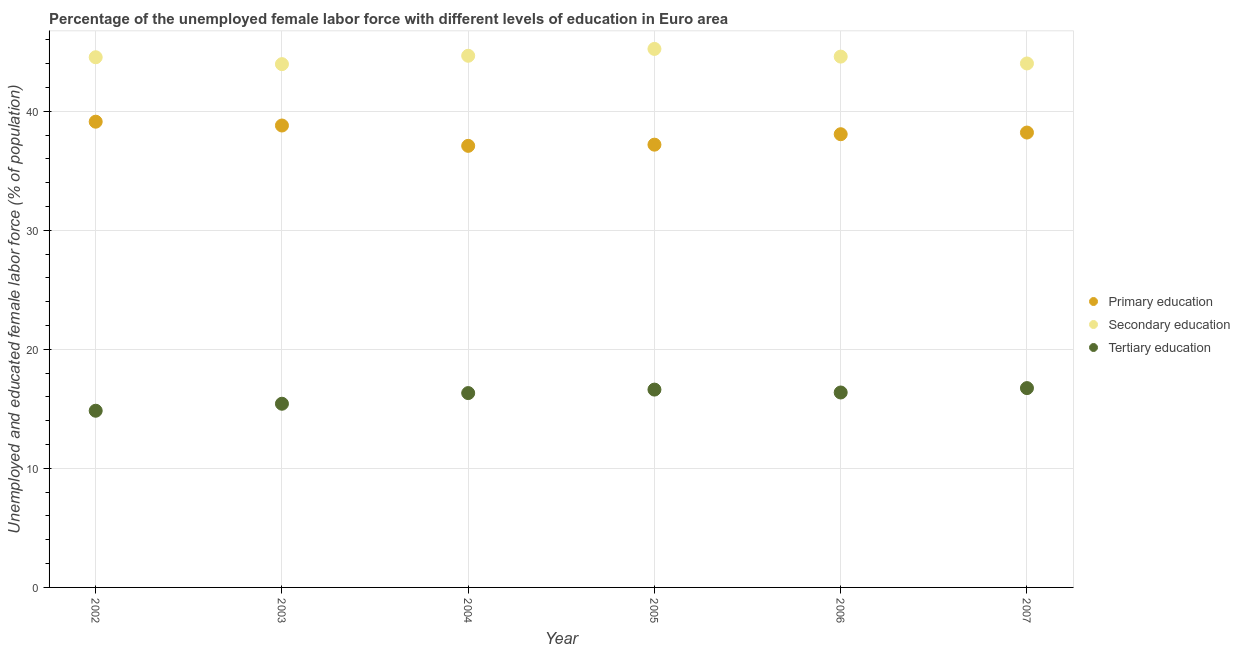What is the percentage of female labor force who received primary education in 2006?
Provide a short and direct response. 38.07. Across all years, what is the maximum percentage of female labor force who received secondary education?
Your answer should be compact. 45.23. Across all years, what is the minimum percentage of female labor force who received secondary education?
Your response must be concise. 43.96. In which year was the percentage of female labor force who received tertiary education maximum?
Your answer should be compact. 2007. What is the total percentage of female labor force who received secondary education in the graph?
Ensure brevity in your answer.  266.99. What is the difference between the percentage of female labor force who received tertiary education in 2002 and that in 2003?
Ensure brevity in your answer.  -0.59. What is the difference between the percentage of female labor force who received tertiary education in 2006 and the percentage of female labor force who received primary education in 2002?
Your answer should be compact. -22.75. What is the average percentage of female labor force who received primary education per year?
Provide a succinct answer. 38.08. In the year 2003, what is the difference between the percentage of female labor force who received secondary education and percentage of female labor force who received primary education?
Offer a terse response. 5.16. What is the ratio of the percentage of female labor force who received tertiary education in 2002 to that in 2005?
Give a very brief answer. 0.89. Is the percentage of female labor force who received primary education in 2002 less than that in 2003?
Provide a succinct answer. No. What is the difference between the highest and the second highest percentage of female labor force who received secondary education?
Your answer should be compact. 0.58. What is the difference between the highest and the lowest percentage of female labor force who received tertiary education?
Offer a terse response. 1.9. Is it the case that in every year, the sum of the percentage of female labor force who received primary education and percentage of female labor force who received secondary education is greater than the percentage of female labor force who received tertiary education?
Your answer should be very brief. Yes. Is the percentage of female labor force who received primary education strictly less than the percentage of female labor force who received tertiary education over the years?
Your answer should be very brief. No. How many dotlines are there?
Your answer should be very brief. 3. What is the difference between two consecutive major ticks on the Y-axis?
Your response must be concise. 10. Are the values on the major ticks of Y-axis written in scientific E-notation?
Your answer should be compact. No. Does the graph contain grids?
Ensure brevity in your answer.  Yes. How many legend labels are there?
Give a very brief answer. 3. How are the legend labels stacked?
Provide a succinct answer. Vertical. What is the title of the graph?
Provide a succinct answer. Percentage of the unemployed female labor force with different levels of education in Euro area. Does "Central government" appear as one of the legend labels in the graph?
Give a very brief answer. No. What is the label or title of the Y-axis?
Offer a terse response. Unemployed and educated female labor force (% of population). What is the Unemployed and educated female labor force (% of population) in Primary education in 2002?
Give a very brief answer. 39.12. What is the Unemployed and educated female labor force (% of population) in Secondary education in 2002?
Keep it short and to the point. 44.53. What is the Unemployed and educated female labor force (% of population) of Tertiary education in 2002?
Your answer should be compact. 14.84. What is the Unemployed and educated female labor force (% of population) of Primary education in 2003?
Your answer should be very brief. 38.8. What is the Unemployed and educated female labor force (% of population) in Secondary education in 2003?
Offer a terse response. 43.96. What is the Unemployed and educated female labor force (% of population) of Tertiary education in 2003?
Offer a very short reply. 15.43. What is the Unemployed and educated female labor force (% of population) of Primary education in 2004?
Keep it short and to the point. 37.09. What is the Unemployed and educated female labor force (% of population) in Secondary education in 2004?
Offer a very short reply. 44.66. What is the Unemployed and educated female labor force (% of population) of Tertiary education in 2004?
Provide a short and direct response. 16.32. What is the Unemployed and educated female labor force (% of population) of Primary education in 2005?
Offer a terse response. 37.19. What is the Unemployed and educated female labor force (% of population) in Secondary education in 2005?
Your response must be concise. 45.23. What is the Unemployed and educated female labor force (% of population) of Tertiary education in 2005?
Offer a very short reply. 16.62. What is the Unemployed and educated female labor force (% of population) of Primary education in 2006?
Offer a very short reply. 38.07. What is the Unemployed and educated female labor force (% of population) in Secondary education in 2006?
Keep it short and to the point. 44.59. What is the Unemployed and educated female labor force (% of population) of Tertiary education in 2006?
Your response must be concise. 16.37. What is the Unemployed and educated female labor force (% of population) of Primary education in 2007?
Give a very brief answer. 38.21. What is the Unemployed and educated female labor force (% of population) of Secondary education in 2007?
Provide a succinct answer. 44.01. What is the Unemployed and educated female labor force (% of population) in Tertiary education in 2007?
Make the answer very short. 16.74. Across all years, what is the maximum Unemployed and educated female labor force (% of population) of Primary education?
Make the answer very short. 39.12. Across all years, what is the maximum Unemployed and educated female labor force (% of population) in Secondary education?
Ensure brevity in your answer.  45.23. Across all years, what is the maximum Unemployed and educated female labor force (% of population) in Tertiary education?
Your answer should be very brief. 16.74. Across all years, what is the minimum Unemployed and educated female labor force (% of population) in Primary education?
Your response must be concise. 37.09. Across all years, what is the minimum Unemployed and educated female labor force (% of population) of Secondary education?
Make the answer very short. 43.96. Across all years, what is the minimum Unemployed and educated female labor force (% of population) of Tertiary education?
Your answer should be very brief. 14.84. What is the total Unemployed and educated female labor force (% of population) in Primary education in the graph?
Your answer should be very brief. 228.48. What is the total Unemployed and educated female labor force (% of population) in Secondary education in the graph?
Offer a terse response. 266.99. What is the total Unemployed and educated female labor force (% of population) in Tertiary education in the graph?
Your response must be concise. 96.33. What is the difference between the Unemployed and educated female labor force (% of population) in Primary education in 2002 and that in 2003?
Your answer should be very brief. 0.32. What is the difference between the Unemployed and educated female labor force (% of population) in Secondary education in 2002 and that in 2003?
Make the answer very short. 0.58. What is the difference between the Unemployed and educated female labor force (% of population) in Tertiary education in 2002 and that in 2003?
Give a very brief answer. -0.59. What is the difference between the Unemployed and educated female labor force (% of population) in Primary education in 2002 and that in 2004?
Your answer should be very brief. 2.03. What is the difference between the Unemployed and educated female labor force (% of population) of Secondary education in 2002 and that in 2004?
Your answer should be very brief. -0.12. What is the difference between the Unemployed and educated female labor force (% of population) in Tertiary education in 2002 and that in 2004?
Offer a terse response. -1.48. What is the difference between the Unemployed and educated female labor force (% of population) in Primary education in 2002 and that in 2005?
Provide a succinct answer. 1.93. What is the difference between the Unemployed and educated female labor force (% of population) of Tertiary education in 2002 and that in 2005?
Offer a terse response. -1.78. What is the difference between the Unemployed and educated female labor force (% of population) in Primary education in 2002 and that in 2006?
Offer a terse response. 1.05. What is the difference between the Unemployed and educated female labor force (% of population) of Secondary education in 2002 and that in 2006?
Keep it short and to the point. -0.05. What is the difference between the Unemployed and educated female labor force (% of population) of Tertiary education in 2002 and that in 2006?
Give a very brief answer. -1.53. What is the difference between the Unemployed and educated female labor force (% of population) in Primary education in 2002 and that in 2007?
Give a very brief answer. 0.91. What is the difference between the Unemployed and educated female labor force (% of population) of Secondary education in 2002 and that in 2007?
Your answer should be very brief. 0.52. What is the difference between the Unemployed and educated female labor force (% of population) of Tertiary education in 2002 and that in 2007?
Your answer should be compact. -1.9. What is the difference between the Unemployed and educated female labor force (% of population) in Primary education in 2003 and that in 2004?
Your answer should be compact. 1.71. What is the difference between the Unemployed and educated female labor force (% of population) of Secondary education in 2003 and that in 2004?
Keep it short and to the point. -0.7. What is the difference between the Unemployed and educated female labor force (% of population) in Tertiary education in 2003 and that in 2004?
Your answer should be very brief. -0.9. What is the difference between the Unemployed and educated female labor force (% of population) in Primary education in 2003 and that in 2005?
Offer a very short reply. 1.61. What is the difference between the Unemployed and educated female labor force (% of population) of Secondary education in 2003 and that in 2005?
Offer a very short reply. -1.28. What is the difference between the Unemployed and educated female labor force (% of population) in Tertiary education in 2003 and that in 2005?
Ensure brevity in your answer.  -1.19. What is the difference between the Unemployed and educated female labor force (% of population) in Primary education in 2003 and that in 2006?
Your response must be concise. 0.73. What is the difference between the Unemployed and educated female labor force (% of population) in Secondary education in 2003 and that in 2006?
Provide a succinct answer. -0.63. What is the difference between the Unemployed and educated female labor force (% of population) of Tertiary education in 2003 and that in 2006?
Your answer should be compact. -0.94. What is the difference between the Unemployed and educated female labor force (% of population) of Primary education in 2003 and that in 2007?
Your answer should be compact. 0.59. What is the difference between the Unemployed and educated female labor force (% of population) of Secondary education in 2003 and that in 2007?
Your response must be concise. -0.06. What is the difference between the Unemployed and educated female labor force (% of population) in Tertiary education in 2003 and that in 2007?
Your response must be concise. -1.31. What is the difference between the Unemployed and educated female labor force (% of population) of Primary education in 2004 and that in 2005?
Offer a very short reply. -0.1. What is the difference between the Unemployed and educated female labor force (% of population) of Secondary education in 2004 and that in 2005?
Provide a succinct answer. -0.58. What is the difference between the Unemployed and educated female labor force (% of population) of Tertiary education in 2004 and that in 2005?
Your response must be concise. -0.29. What is the difference between the Unemployed and educated female labor force (% of population) in Primary education in 2004 and that in 2006?
Offer a terse response. -0.98. What is the difference between the Unemployed and educated female labor force (% of population) in Secondary education in 2004 and that in 2006?
Provide a succinct answer. 0.07. What is the difference between the Unemployed and educated female labor force (% of population) in Tertiary education in 2004 and that in 2006?
Give a very brief answer. -0.05. What is the difference between the Unemployed and educated female labor force (% of population) in Primary education in 2004 and that in 2007?
Ensure brevity in your answer.  -1.12. What is the difference between the Unemployed and educated female labor force (% of population) of Secondary education in 2004 and that in 2007?
Your response must be concise. 0.65. What is the difference between the Unemployed and educated female labor force (% of population) in Tertiary education in 2004 and that in 2007?
Provide a short and direct response. -0.42. What is the difference between the Unemployed and educated female labor force (% of population) of Primary education in 2005 and that in 2006?
Your answer should be compact. -0.88. What is the difference between the Unemployed and educated female labor force (% of population) of Secondary education in 2005 and that in 2006?
Offer a terse response. 0.65. What is the difference between the Unemployed and educated female labor force (% of population) of Tertiary education in 2005 and that in 2006?
Offer a terse response. 0.24. What is the difference between the Unemployed and educated female labor force (% of population) in Primary education in 2005 and that in 2007?
Provide a succinct answer. -1.02. What is the difference between the Unemployed and educated female labor force (% of population) in Secondary education in 2005 and that in 2007?
Offer a terse response. 1.22. What is the difference between the Unemployed and educated female labor force (% of population) in Tertiary education in 2005 and that in 2007?
Provide a succinct answer. -0.12. What is the difference between the Unemployed and educated female labor force (% of population) of Primary education in 2006 and that in 2007?
Give a very brief answer. -0.14. What is the difference between the Unemployed and educated female labor force (% of population) in Secondary education in 2006 and that in 2007?
Your response must be concise. 0.58. What is the difference between the Unemployed and educated female labor force (% of population) of Tertiary education in 2006 and that in 2007?
Make the answer very short. -0.37. What is the difference between the Unemployed and educated female labor force (% of population) in Primary education in 2002 and the Unemployed and educated female labor force (% of population) in Secondary education in 2003?
Keep it short and to the point. -4.83. What is the difference between the Unemployed and educated female labor force (% of population) of Primary education in 2002 and the Unemployed and educated female labor force (% of population) of Tertiary education in 2003?
Ensure brevity in your answer.  23.69. What is the difference between the Unemployed and educated female labor force (% of population) in Secondary education in 2002 and the Unemployed and educated female labor force (% of population) in Tertiary education in 2003?
Your response must be concise. 29.1. What is the difference between the Unemployed and educated female labor force (% of population) in Primary education in 2002 and the Unemployed and educated female labor force (% of population) in Secondary education in 2004?
Provide a succinct answer. -5.54. What is the difference between the Unemployed and educated female labor force (% of population) in Primary education in 2002 and the Unemployed and educated female labor force (% of population) in Tertiary education in 2004?
Your answer should be compact. 22.8. What is the difference between the Unemployed and educated female labor force (% of population) of Secondary education in 2002 and the Unemployed and educated female labor force (% of population) of Tertiary education in 2004?
Ensure brevity in your answer.  28.21. What is the difference between the Unemployed and educated female labor force (% of population) in Primary education in 2002 and the Unemployed and educated female labor force (% of population) in Secondary education in 2005?
Keep it short and to the point. -6.11. What is the difference between the Unemployed and educated female labor force (% of population) in Primary education in 2002 and the Unemployed and educated female labor force (% of population) in Tertiary education in 2005?
Keep it short and to the point. 22.5. What is the difference between the Unemployed and educated female labor force (% of population) in Secondary education in 2002 and the Unemployed and educated female labor force (% of population) in Tertiary education in 2005?
Offer a very short reply. 27.92. What is the difference between the Unemployed and educated female labor force (% of population) of Primary education in 2002 and the Unemployed and educated female labor force (% of population) of Secondary education in 2006?
Ensure brevity in your answer.  -5.47. What is the difference between the Unemployed and educated female labor force (% of population) of Primary education in 2002 and the Unemployed and educated female labor force (% of population) of Tertiary education in 2006?
Offer a terse response. 22.75. What is the difference between the Unemployed and educated female labor force (% of population) of Secondary education in 2002 and the Unemployed and educated female labor force (% of population) of Tertiary education in 2006?
Provide a succinct answer. 28.16. What is the difference between the Unemployed and educated female labor force (% of population) of Primary education in 2002 and the Unemployed and educated female labor force (% of population) of Secondary education in 2007?
Offer a very short reply. -4.89. What is the difference between the Unemployed and educated female labor force (% of population) in Primary education in 2002 and the Unemployed and educated female labor force (% of population) in Tertiary education in 2007?
Provide a short and direct response. 22.38. What is the difference between the Unemployed and educated female labor force (% of population) of Secondary education in 2002 and the Unemployed and educated female labor force (% of population) of Tertiary education in 2007?
Provide a short and direct response. 27.79. What is the difference between the Unemployed and educated female labor force (% of population) of Primary education in 2003 and the Unemployed and educated female labor force (% of population) of Secondary education in 2004?
Keep it short and to the point. -5.86. What is the difference between the Unemployed and educated female labor force (% of population) in Primary education in 2003 and the Unemployed and educated female labor force (% of population) in Tertiary education in 2004?
Make the answer very short. 22.48. What is the difference between the Unemployed and educated female labor force (% of population) in Secondary education in 2003 and the Unemployed and educated female labor force (% of population) in Tertiary education in 2004?
Your answer should be compact. 27.63. What is the difference between the Unemployed and educated female labor force (% of population) in Primary education in 2003 and the Unemployed and educated female labor force (% of population) in Secondary education in 2005?
Provide a succinct answer. -6.43. What is the difference between the Unemployed and educated female labor force (% of population) in Primary education in 2003 and the Unemployed and educated female labor force (% of population) in Tertiary education in 2005?
Ensure brevity in your answer.  22.18. What is the difference between the Unemployed and educated female labor force (% of population) in Secondary education in 2003 and the Unemployed and educated female labor force (% of population) in Tertiary education in 2005?
Provide a succinct answer. 27.34. What is the difference between the Unemployed and educated female labor force (% of population) in Primary education in 2003 and the Unemployed and educated female labor force (% of population) in Secondary education in 2006?
Make the answer very short. -5.79. What is the difference between the Unemployed and educated female labor force (% of population) in Primary education in 2003 and the Unemployed and educated female labor force (% of population) in Tertiary education in 2006?
Ensure brevity in your answer.  22.43. What is the difference between the Unemployed and educated female labor force (% of population) in Secondary education in 2003 and the Unemployed and educated female labor force (% of population) in Tertiary education in 2006?
Give a very brief answer. 27.58. What is the difference between the Unemployed and educated female labor force (% of population) in Primary education in 2003 and the Unemployed and educated female labor force (% of population) in Secondary education in 2007?
Your response must be concise. -5.21. What is the difference between the Unemployed and educated female labor force (% of population) of Primary education in 2003 and the Unemployed and educated female labor force (% of population) of Tertiary education in 2007?
Offer a terse response. 22.06. What is the difference between the Unemployed and educated female labor force (% of population) in Secondary education in 2003 and the Unemployed and educated female labor force (% of population) in Tertiary education in 2007?
Provide a short and direct response. 27.21. What is the difference between the Unemployed and educated female labor force (% of population) of Primary education in 2004 and the Unemployed and educated female labor force (% of population) of Secondary education in 2005?
Make the answer very short. -8.14. What is the difference between the Unemployed and educated female labor force (% of population) in Primary education in 2004 and the Unemployed and educated female labor force (% of population) in Tertiary education in 2005?
Offer a terse response. 20.47. What is the difference between the Unemployed and educated female labor force (% of population) in Secondary education in 2004 and the Unemployed and educated female labor force (% of population) in Tertiary education in 2005?
Make the answer very short. 28.04. What is the difference between the Unemployed and educated female labor force (% of population) of Primary education in 2004 and the Unemployed and educated female labor force (% of population) of Secondary education in 2006?
Offer a very short reply. -7.5. What is the difference between the Unemployed and educated female labor force (% of population) in Primary education in 2004 and the Unemployed and educated female labor force (% of population) in Tertiary education in 2006?
Make the answer very short. 20.72. What is the difference between the Unemployed and educated female labor force (% of population) in Secondary education in 2004 and the Unemployed and educated female labor force (% of population) in Tertiary education in 2006?
Your answer should be compact. 28.28. What is the difference between the Unemployed and educated female labor force (% of population) in Primary education in 2004 and the Unemployed and educated female labor force (% of population) in Secondary education in 2007?
Your response must be concise. -6.92. What is the difference between the Unemployed and educated female labor force (% of population) of Primary education in 2004 and the Unemployed and educated female labor force (% of population) of Tertiary education in 2007?
Your answer should be compact. 20.35. What is the difference between the Unemployed and educated female labor force (% of population) of Secondary education in 2004 and the Unemployed and educated female labor force (% of population) of Tertiary education in 2007?
Keep it short and to the point. 27.92. What is the difference between the Unemployed and educated female labor force (% of population) of Primary education in 2005 and the Unemployed and educated female labor force (% of population) of Secondary education in 2006?
Keep it short and to the point. -7.4. What is the difference between the Unemployed and educated female labor force (% of population) of Primary education in 2005 and the Unemployed and educated female labor force (% of population) of Tertiary education in 2006?
Provide a succinct answer. 20.82. What is the difference between the Unemployed and educated female labor force (% of population) in Secondary education in 2005 and the Unemployed and educated female labor force (% of population) in Tertiary education in 2006?
Your answer should be very brief. 28.86. What is the difference between the Unemployed and educated female labor force (% of population) of Primary education in 2005 and the Unemployed and educated female labor force (% of population) of Secondary education in 2007?
Give a very brief answer. -6.82. What is the difference between the Unemployed and educated female labor force (% of population) in Primary education in 2005 and the Unemployed and educated female labor force (% of population) in Tertiary education in 2007?
Your answer should be compact. 20.45. What is the difference between the Unemployed and educated female labor force (% of population) in Secondary education in 2005 and the Unemployed and educated female labor force (% of population) in Tertiary education in 2007?
Make the answer very short. 28.49. What is the difference between the Unemployed and educated female labor force (% of population) of Primary education in 2006 and the Unemployed and educated female labor force (% of population) of Secondary education in 2007?
Ensure brevity in your answer.  -5.94. What is the difference between the Unemployed and educated female labor force (% of population) of Primary education in 2006 and the Unemployed and educated female labor force (% of population) of Tertiary education in 2007?
Give a very brief answer. 21.33. What is the difference between the Unemployed and educated female labor force (% of population) in Secondary education in 2006 and the Unemployed and educated female labor force (% of population) in Tertiary education in 2007?
Provide a succinct answer. 27.85. What is the average Unemployed and educated female labor force (% of population) in Primary education per year?
Make the answer very short. 38.08. What is the average Unemployed and educated female labor force (% of population) in Secondary education per year?
Provide a short and direct response. 44.5. What is the average Unemployed and educated female labor force (% of population) in Tertiary education per year?
Ensure brevity in your answer.  16.06. In the year 2002, what is the difference between the Unemployed and educated female labor force (% of population) in Primary education and Unemployed and educated female labor force (% of population) in Secondary education?
Offer a very short reply. -5.41. In the year 2002, what is the difference between the Unemployed and educated female labor force (% of population) in Primary education and Unemployed and educated female labor force (% of population) in Tertiary education?
Ensure brevity in your answer.  24.28. In the year 2002, what is the difference between the Unemployed and educated female labor force (% of population) of Secondary education and Unemployed and educated female labor force (% of population) of Tertiary education?
Provide a succinct answer. 29.69. In the year 2003, what is the difference between the Unemployed and educated female labor force (% of population) of Primary education and Unemployed and educated female labor force (% of population) of Secondary education?
Make the answer very short. -5.16. In the year 2003, what is the difference between the Unemployed and educated female labor force (% of population) in Primary education and Unemployed and educated female labor force (% of population) in Tertiary education?
Provide a short and direct response. 23.37. In the year 2003, what is the difference between the Unemployed and educated female labor force (% of population) in Secondary education and Unemployed and educated female labor force (% of population) in Tertiary education?
Your response must be concise. 28.53. In the year 2004, what is the difference between the Unemployed and educated female labor force (% of population) in Primary education and Unemployed and educated female labor force (% of population) in Secondary education?
Give a very brief answer. -7.57. In the year 2004, what is the difference between the Unemployed and educated female labor force (% of population) of Primary education and Unemployed and educated female labor force (% of population) of Tertiary education?
Your response must be concise. 20.77. In the year 2004, what is the difference between the Unemployed and educated female labor force (% of population) in Secondary education and Unemployed and educated female labor force (% of population) in Tertiary education?
Ensure brevity in your answer.  28.33. In the year 2005, what is the difference between the Unemployed and educated female labor force (% of population) in Primary education and Unemployed and educated female labor force (% of population) in Secondary education?
Offer a terse response. -8.04. In the year 2005, what is the difference between the Unemployed and educated female labor force (% of population) of Primary education and Unemployed and educated female labor force (% of population) of Tertiary education?
Your response must be concise. 20.57. In the year 2005, what is the difference between the Unemployed and educated female labor force (% of population) of Secondary education and Unemployed and educated female labor force (% of population) of Tertiary education?
Your answer should be compact. 28.62. In the year 2006, what is the difference between the Unemployed and educated female labor force (% of population) in Primary education and Unemployed and educated female labor force (% of population) in Secondary education?
Your response must be concise. -6.52. In the year 2006, what is the difference between the Unemployed and educated female labor force (% of population) in Primary education and Unemployed and educated female labor force (% of population) in Tertiary education?
Give a very brief answer. 21.7. In the year 2006, what is the difference between the Unemployed and educated female labor force (% of population) of Secondary education and Unemployed and educated female labor force (% of population) of Tertiary education?
Make the answer very short. 28.21. In the year 2007, what is the difference between the Unemployed and educated female labor force (% of population) in Primary education and Unemployed and educated female labor force (% of population) in Secondary education?
Provide a short and direct response. -5.8. In the year 2007, what is the difference between the Unemployed and educated female labor force (% of population) in Primary education and Unemployed and educated female labor force (% of population) in Tertiary education?
Your response must be concise. 21.47. In the year 2007, what is the difference between the Unemployed and educated female labor force (% of population) in Secondary education and Unemployed and educated female labor force (% of population) in Tertiary education?
Make the answer very short. 27.27. What is the ratio of the Unemployed and educated female labor force (% of population) of Primary education in 2002 to that in 2003?
Your answer should be compact. 1.01. What is the ratio of the Unemployed and educated female labor force (% of population) in Secondary education in 2002 to that in 2003?
Keep it short and to the point. 1.01. What is the ratio of the Unemployed and educated female labor force (% of population) of Tertiary education in 2002 to that in 2003?
Provide a succinct answer. 0.96. What is the ratio of the Unemployed and educated female labor force (% of population) of Primary education in 2002 to that in 2004?
Ensure brevity in your answer.  1.05. What is the ratio of the Unemployed and educated female labor force (% of population) in Tertiary education in 2002 to that in 2004?
Give a very brief answer. 0.91. What is the ratio of the Unemployed and educated female labor force (% of population) of Primary education in 2002 to that in 2005?
Offer a terse response. 1.05. What is the ratio of the Unemployed and educated female labor force (% of population) of Secondary education in 2002 to that in 2005?
Your answer should be compact. 0.98. What is the ratio of the Unemployed and educated female labor force (% of population) in Tertiary education in 2002 to that in 2005?
Give a very brief answer. 0.89. What is the ratio of the Unemployed and educated female labor force (% of population) of Primary education in 2002 to that in 2006?
Provide a short and direct response. 1.03. What is the ratio of the Unemployed and educated female labor force (% of population) of Tertiary education in 2002 to that in 2006?
Provide a succinct answer. 0.91. What is the ratio of the Unemployed and educated female labor force (% of population) in Primary education in 2002 to that in 2007?
Give a very brief answer. 1.02. What is the ratio of the Unemployed and educated female labor force (% of population) of Secondary education in 2002 to that in 2007?
Offer a very short reply. 1.01. What is the ratio of the Unemployed and educated female labor force (% of population) of Tertiary education in 2002 to that in 2007?
Offer a terse response. 0.89. What is the ratio of the Unemployed and educated female labor force (% of population) of Primary education in 2003 to that in 2004?
Keep it short and to the point. 1.05. What is the ratio of the Unemployed and educated female labor force (% of population) of Secondary education in 2003 to that in 2004?
Your answer should be very brief. 0.98. What is the ratio of the Unemployed and educated female labor force (% of population) in Tertiary education in 2003 to that in 2004?
Offer a terse response. 0.95. What is the ratio of the Unemployed and educated female labor force (% of population) of Primary education in 2003 to that in 2005?
Provide a short and direct response. 1.04. What is the ratio of the Unemployed and educated female labor force (% of population) in Secondary education in 2003 to that in 2005?
Your answer should be very brief. 0.97. What is the ratio of the Unemployed and educated female labor force (% of population) in Tertiary education in 2003 to that in 2005?
Provide a succinct answer. 0.93. What is the ratio of the Unemployed and educated female labor force (% of population) of Primary education in 2003 to that in 2006?
Provide a succinct answer. 1.02. What is the ratio of the Unemployed and educated female labor force (% of population) of Secondary education in 2003 to that in 2006?
Give a very brief answer. 0.99. What is the ratio of the Unemployed and educated female labor force (% of population) of Tertiary education in 2003 to that in 2006?
Provide a succinct answer. 0.94. What is the ratio of the Unemployed and educated female labor force (% of population) of Primary education in 2003 to that in 2007?
Provide a succinct answer. 1.02. What is the ratio of the Unemployed and educated female labor force (% of population) of Secondary education in 2003 to that in 2007?
Your response must be concise. 1. What is the ratio of the Unemployed and educated female labor force (% of population) of Tertiary education in 2003 to that in 2007?
Your response must be concise. 0.92. What is the ratio of the Unemployed and educated female labor force (% of population) in Secondary education in 2004 to that in 2005?
Offer a terse response. 0.99. What is the ratio of the Unemployed and educated female labor force (% of population) of Tertiary education in 2004 to that in 2005?
Offer a very short reply. 0.98. What is the ratio of the Unemployed and educated female labor force (% of population) in Primary education in 2004 to that in 2006?
Keep it short and to the point. 0.97. What is the ratio of the Unemployed and educated female labor force (% of population) of Tertiary education in 2004 to that in 2006?
Make the answer very short. 1. What is the ratio of the Unemployed and educated female labor force (% of population) in Primary education in 2004 to that in 2007?
Provide a short and direct response. 0.97. What is the ratio of the Unemployed and educated female labor force (% of population) of Secondary education in 2004 to that in 2007?
Offer a very short reply. 1.01. What is the ratio of the Unemployed and educated female labor force (% of population) of Primary education in 2005 to that in 2006?
Provide a short and direct response. 0.98. What is the ratio of the Unemployed and educated female labor force (% of population) of Secondary education in 2005 to that in 2006?
Keep it short and to the point. 1.01. What is the ratio of the Unemployed and educated female labor force (% of population) in Tertiary education in 2005 to that in 2006?
Ensure brevity in your answer.  1.01. What is the ratio of the Unemployed and educated female labor force (% of population) of Primary education in 2005 to that in 2007?
Offer a very short reply. 0.97. What is the ratio of the Unemployed and educated female labor force (% of population) of Secondary education in 2005 to that in 2007?
Make the answer very short. 1.03. What is the ratio of the Unemployed and educated female labor force (% of population) in Secondary education in 2006 to that in 2007?
Ensure brevity in your answer.  1.01. What is the difference between the highest and the second highest Unemployed and educated female labor force (% of population) in Primary education?
Your answer should be very brief. 0.32. What is the difference between the highest and the second highest Unemployed and educated female labor force (% of population) in Secondary education?
Offer a terse response. 0.58. What is the difference between the highest and the second highest Unemployed and educated female labor force (% of population) of Tertiary education?
Provide a succinct answer. 0.12. What is the difference between the highest and the lowest Unemployed and educated female labor force (% of population) of Primary education?
Your answer should be compact. 2.03. What is the difference between the highest and the lowest Unemployed and educated female labor force (% of population) in Secondary education?
Your response must be concise. 1.28. What is the difference between the highest and the lowest Unemployed and educated female labor force (% of population) of Tertiary education?
Provide a short and direct response. 1.9. 